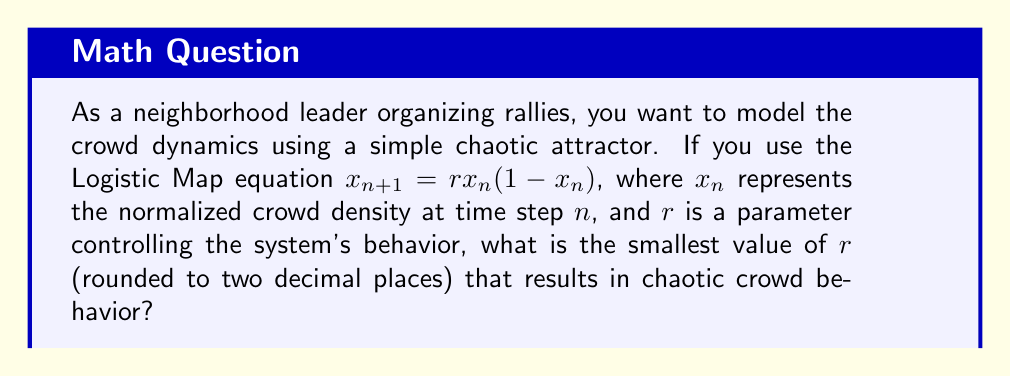What is the answer to this math problem? To solve this problem, we need to understand the behavior of the Logistic Map for different values of $r$:

1. For $0 < r < 1$, the system converges to 0.
2. For $1 < r < 3$, the system converges to a single fixed point.
3. For $3 < r < 3.57$ (approximately), the system oscillates between multiple values.
4. For $r > 3.57$ (approximately), the system exhibits chaotic behavior.

The transition to chaos occurs at approximately $r = 3.57$. This value is known as the onset of chaos for the Logistic Map.

To find the precise value, we can use the period-doubling cascade:

1. At $r = 3$, the system transitions from a single fixed point to oscillating between two values.
2. As $r$ increases, the system undergoes further period-doubling bifurcations.
3. The accumulation point of these period-doubling bifurcations is the onset of chaos.

The exact value for the onset of chaos is the Feigenbaum point:

$$r_∞ ≈ 3.5699456718...$$

Rounding this value to two decimal places gives us 3.57.
Answer: 3.57 